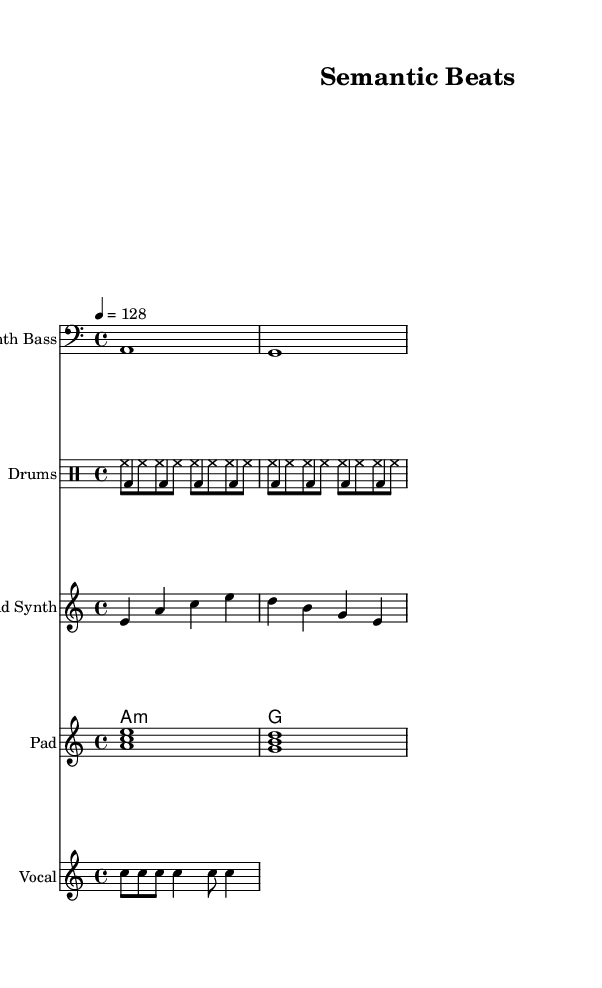What is the key signature of this music? The key signature is indicated at the beginning of the score, and it shows an "A minor" key, which has no sharps or flats.
Answer: A minor What is the time signature of this music? The time signature is represented by two numbers, where the upper number shows how many beats are in a measure and the lower number tells the value of the beats. Here, it indicates 4/4 time, meaning there are four beats per measure and the quarter note receives one beat.
Answer: 4/4 What is the tempo of this music? The tempo is marked for the entire piece, and in this score, it is indicated as "4 = 128", which means 128 beats per minute.
Answer: 128 How many vocal phrases are in the vocal sample? The lyric line shows "Se - man - tic Struc - ture", split into five distinct syllables or phrases. Counting these gives a total of five phrases.
Answer: 5 How many different drum voices are used in this piece? The score uses two distinct drum voices, as identified in the "DrumStaff", which includes "kickDrum" and "hiHat". The presence of both indicates that there are exactly two different drum voices.
Answer: 2 What is the primary function of the synth bass in this music? The synth bass is typically used to establish the harmonic foundation of the piece, and in this score, it plays two notes, which also helps set the mood and groove characteristic of House music.
Answer: Establish harmonic foundation What type of chord is used in the pad section? The chord is indicated in chord mode as "a1:m", meaning it is an A minor chord. The notation specifically shows that it is minor.
Answer: A minor 